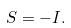<formula> <loc_0><loc_0><loc_500><loc_500>S = - I .</formula> 